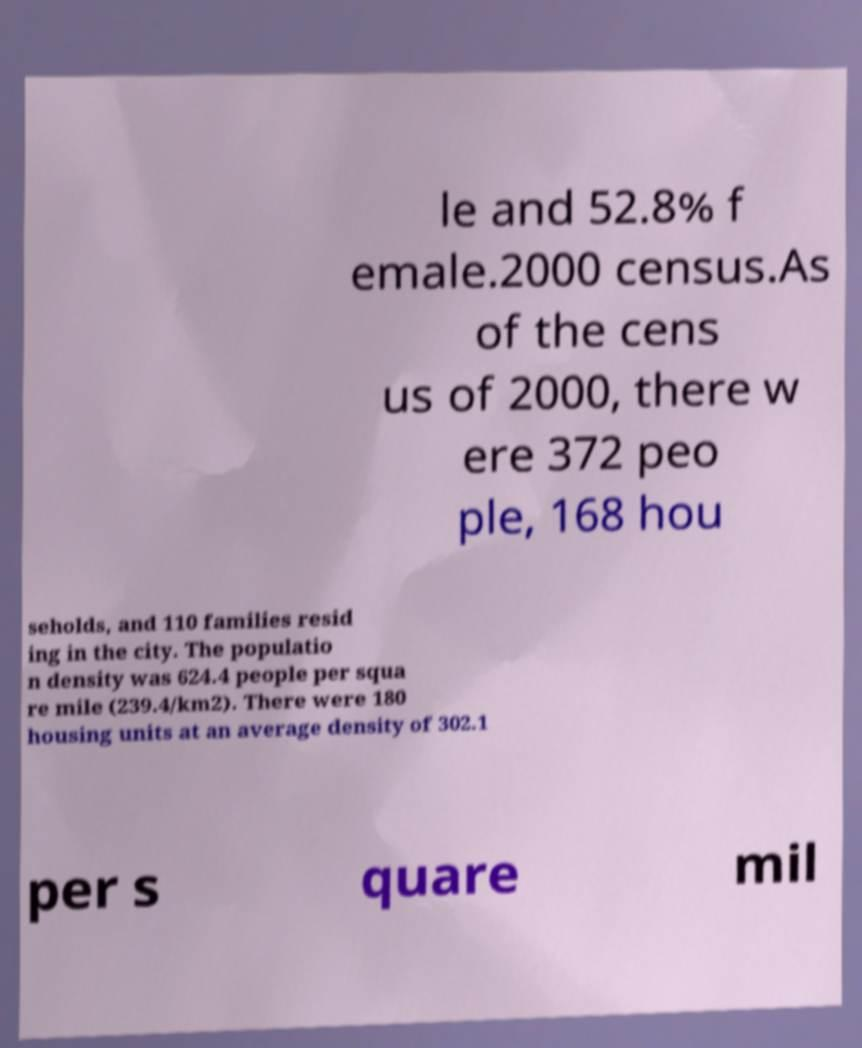Could you assist in decoding the text presented in this image and type it out clearly? le and 52.8% f emale.2000 census.As of the cens us of 2000, there w ere 372 peo ple, 168 hou seholds, and 110 families resid ing in the city. The populatio n density was 624.4 people per squa re mile (239.4/km2). There were 180 housing units at an average density of 302.1 per s quare mil 